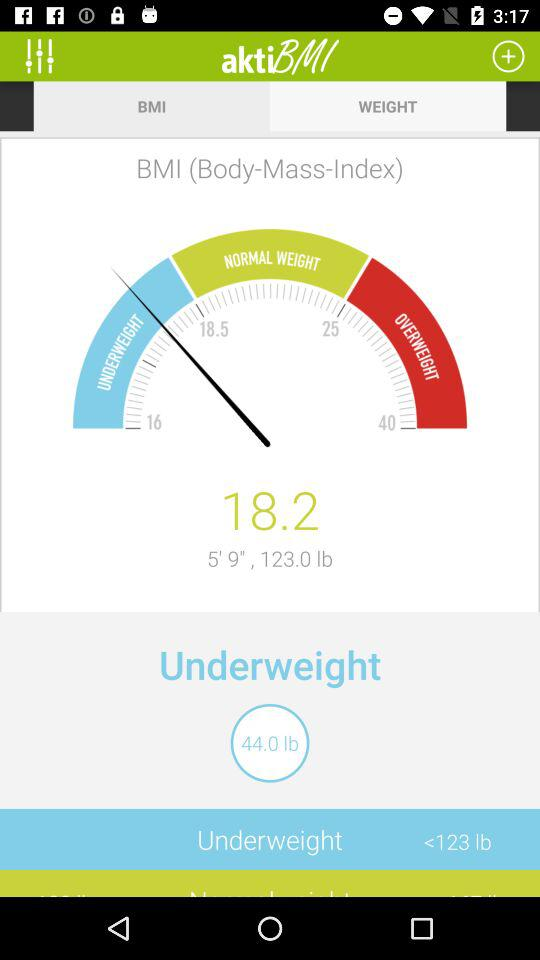What is the weight in lb? The weight in lb is 123. 